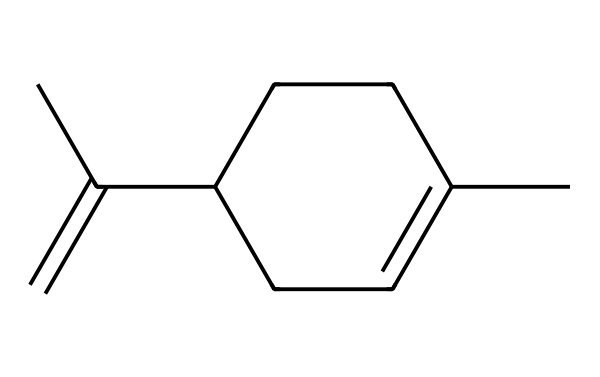What is the molecular formula of limonene? By analyzing the given SMILES representation, we can determine the composition of the molecule. Limonene has 10 carbon atoms (C) and 16 hydrogen atoms (H), leading to the molecular formula C10H16.
Answer: C10H16 How many double bonds are present in this molecule? In the provided structure, we can visually assess the number of double bonds by looking for double bond indicators between atoms. Limonene contains one double bond in its structure.
Answer: 1 What type of hydrocarbon is limonene classified as? Limonene is based on the structure of a cyclic compound, specifically having a ring structure with one double bond, making it a cyclic monoterpene.
Answer: cyclic monoterpene Is limonene polar or nonpolar? Given the structure of limonene, the symmetrical arrangement of carbon and hydrogen leads to a nonpolar molecule, as there are no significant electronegative atoms or functional groups present.
Answer: nonpolar What is the characteristic scent attributed to limonene? The presence of limonene in the chemical structure is widely known to provide a citrus scent, characteristic of citrus fruits such as oranges and lemons.
Answer: citrus How many hydrogen atoms are attached to the terminal carbon atoms? By analyzing the structure and the arrangement of the carbon atoms, we can identify that there are three terminal carbon atoms, and each of these typically has three hydrogen atoms attached, totaling nine hydrogen atoms at the terminals.
Answer: 9 Which property of limonene makes it useful in eco-friendly cleaning products? The low toxicity and biodegradable nature of limonene, arising from its simple structure, make it an effective and eco-friendly choice compared to synthetic chemicals in cleaning products.
Answer: low toxicity 